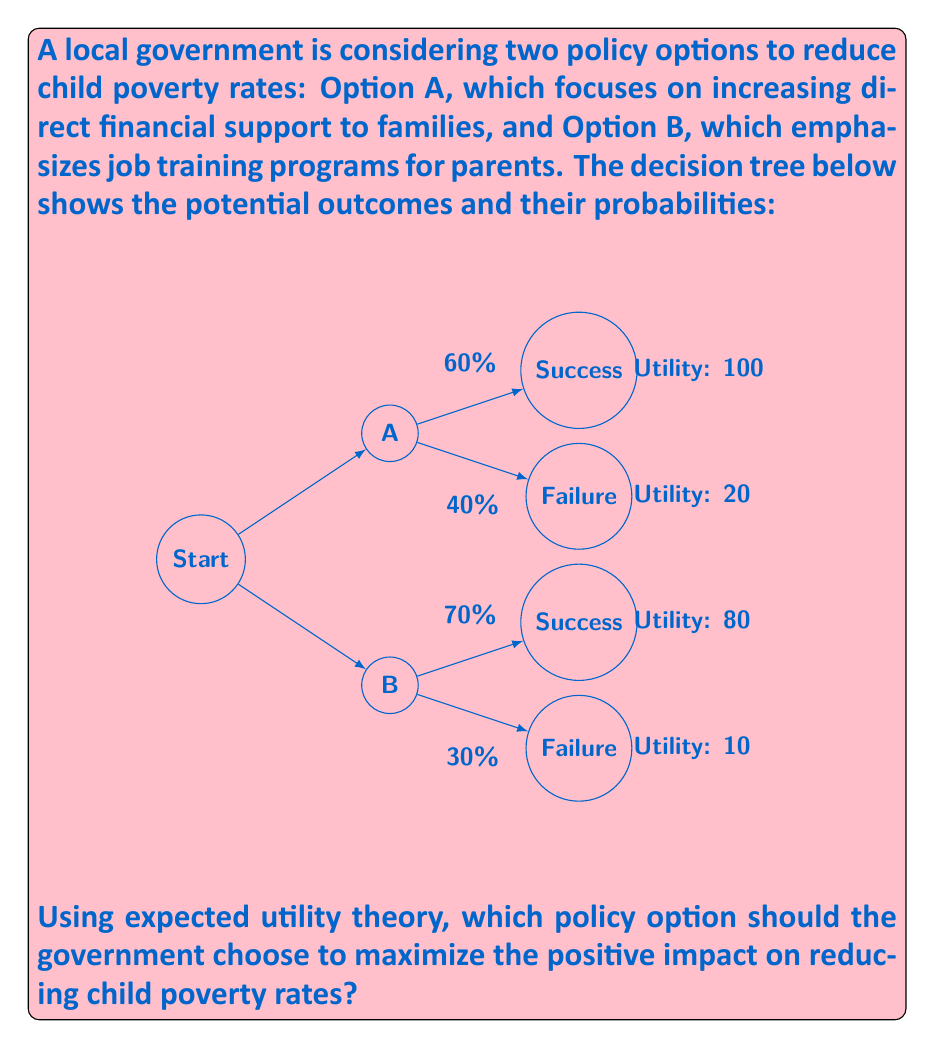Provide a solution to this math problem. To solve this problem, we need to calculate the expected utility for each policy option and compare them.

1. Calculate the expected utility for Option A:
   $$E(U_A) = 0.60 \times 100 + 0.40 \times 20$$
   $$E(U_A) = 60 + 8 = 68$$

2. Calculate the expected utility for Option B:
   $$E(U_B) = 0.70 \times 80 + 0.30 \times 10$$
   $$E(U_B) = 56 + 3 = 59$$

3. Compare the expected utilities:
   Option A has a higher expected utility (68) compared to Option B (59).

The expected utility theory suggests that rational decision-makers should choose the option with the highest expected utility. In this case, Option A (increasing direct financial support to families) has a higher expected utility than Option B (job training programs for parents).

This result aligns with the perspective of a children's rights activist, as direct financial support can have an immediate and tangible impact on reducing child poverty rates. While job training programs can be beneficial in the long run, they may not address the immediate needs of children living in poverty as effectively as direct financial assistance.
Answer: The government should choose Option A (increasing direct financial support to families) as it has a higher expected utility of 68 compared to Option B's expected utility of 59. 